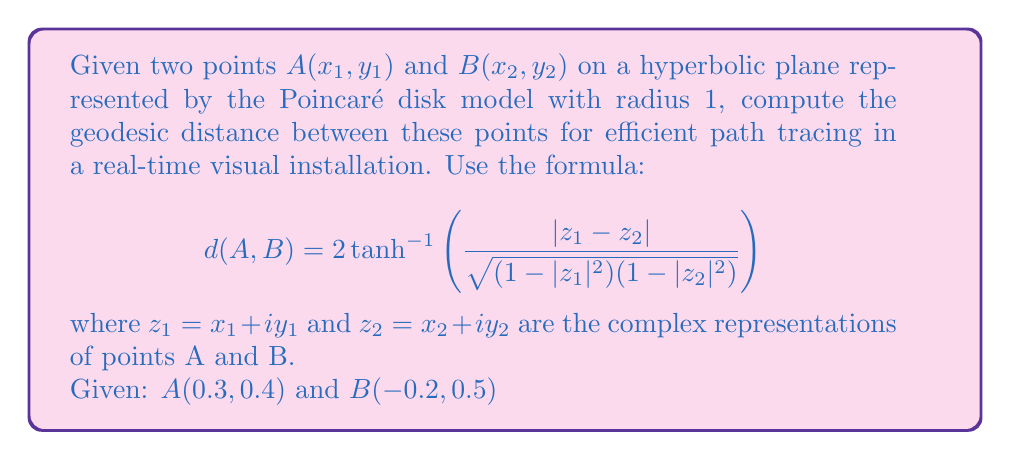Help me with this question. To solve this problem, we'll follow these steps:

1) Convert the given points to complex numbers:
   $z_1 = 0.3 + 0.4i$
   $z_2 = -0.2 + 0.5i$

2) Calculate $|z_1 - z_2|$:
   $|z_1 - z_2| = |0.3 + 0.4i - (-0.2 + 0.5i)|$
                $= |0.5 - 0.1i|$
                $= \sqrt{0.5^2 + (-0.1)^2}$
                $= \sqrt{0.26}$
                $\approx 0.5099$

3) Calculate $|z_1|^2$ and $|z_2|^2$:
   $|z_1|^2 = 0.3^2 + 0.4^2 = 0.25$
   $|z_2|^2 = (-0.2)^2 + 0.5^2 = 0.29$

4) Calculate $(1-|z_1|^2)(1-|z_2|^2)$:
   $(1-0.25)(1-0.29) = 0.75 * 0.71 = 0.5325$

5) Calculate the fraction inside the $\tanh^{-1}$ function:
   $\frac{|z_1 - z_2|}{\sqrt{(1-|z_1|^2)(1-|z_2|^2)}} = \frac{0.5099}{\sqrt{0.5325}} \approx 0.6996$

6) Apply the formula:
   $d(A,B) = 2 \tanh^{-1}(0.6996) \approx 2 * 0.8679 \approx 1.7358$

Therefore, the geodesic distance between A and B is approximately 1.7358.
Answer: $1.7358$ 